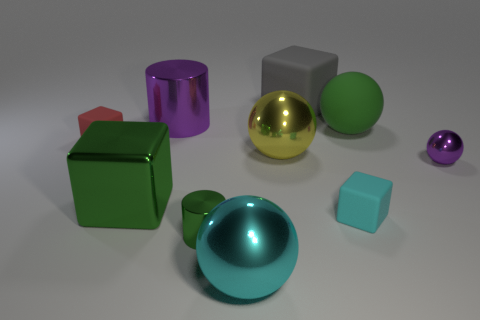Subtract all cubes. How many objects are left? 6 Add 1 tiny green metallic cylinders. How many tiny green metallic cylinders exist? 2 Subtract 1 yellow spheres. How many objects are left? 9 Subtract all small purple blocks. Subtract all large cyan things. How many objects are left? 9 Add 9 large yellow shiny balls. How many large yellow shiny balls are left? 10 